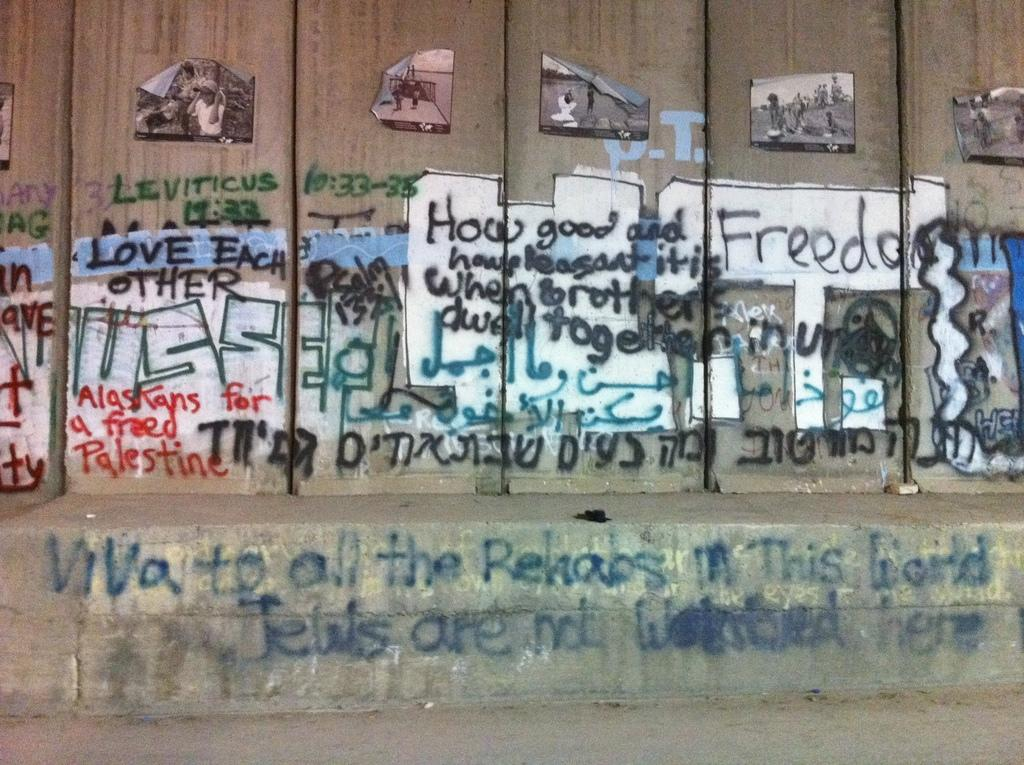What is the main feature of the image? There is a wall in the image. What is on the wall? There is graffiti and posters on the wall. Can you describe the text in the image? There is text in the image, including on the wall at the bottom. What is the setting of the image? There is a walkway at the bottom of the image. What type of boats can be seen in the image? There are no boats present in the image. What does the graffiti on the wall express in terms of regret? The graffiti on the wall does not express any emotions or regrets, as it is simply a visual element in the image. 